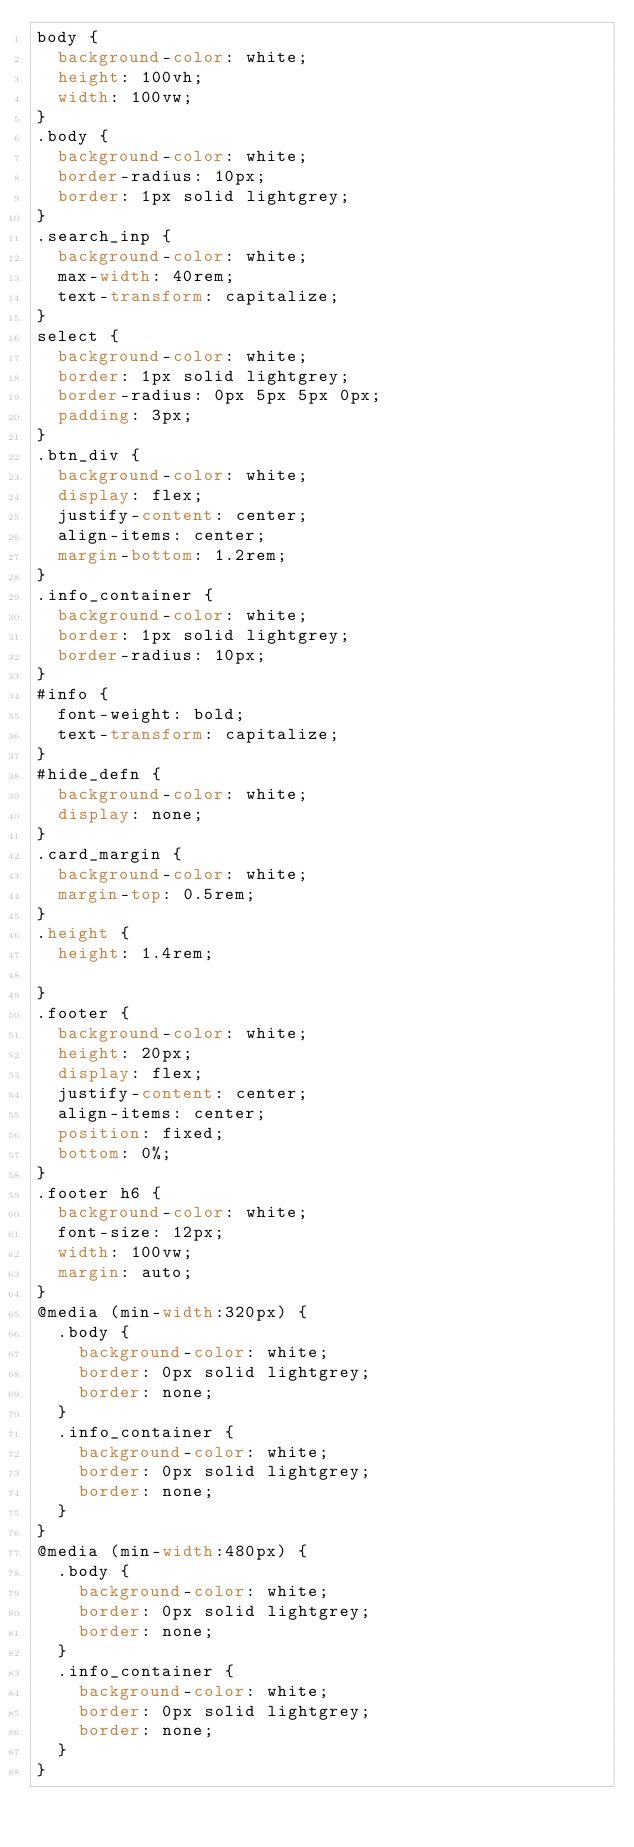Convert code to text. <code><loc_0><loc_0><loc_500><loc_500><_CSS_>body {
  background-color: white;
  height: 100vh;
  width: 100vw;
}
.body {
  background-color: white;
  border-radius: 10px;
  border: 1px solid lightgrey;
}
.search_inp {
  background-color: white;
  max-width: 40rem;
  text-transform: capitalize;
}
select {
  background-color: white;
  border: 1px solid lightgrey;
  border-radius: 0px 5px 5px 0px;
  padding: 3px;
}
.btn_div {
  background-color: white;
  display: flex;
  justify-content: center;
  align-items: center;
  margin-bottom: 1.2rem;
}
.info_container {
  background-color: white;
  border: 1px solid lightgrey;
  border-radius: 10px;
}
#info {
  font-weight: bold;
  text-transform: capitalize;
}
#hide_defn {
  background-color: white;
  display: none;
}
.card_margin {
  background-color: white;
  margin-top: 0.5rem;
}
.height {
  height: 1.4rem;

}
.footer {
  background-color: white;
  height: 20px;
  display: flex;
  justify-content: center;
  align-items: center;
  position: fixed;
  bottom: 0%;
}
.footer h6 {
  background-color: white;
  font-size: 12px;
  width: 100vw;
  margin: auto;
}
@media (min-width:320px) {
  .body {
    background-color: white;
    border: 0px solid lightgrey;
    border: none;
  }
  .info_container {
    background-color: white;
    border: 0px solid lightgrey;
    border: none;
  }
}
@media (min-width:480px) {
  .body {
    background-color: white;
    border: 0px solid lightgrey;
    border: none;
  }
  .info_container {
    background-color: white;
    border: 0px solid lightgrey;
    border: none;
  }
}
</code> 